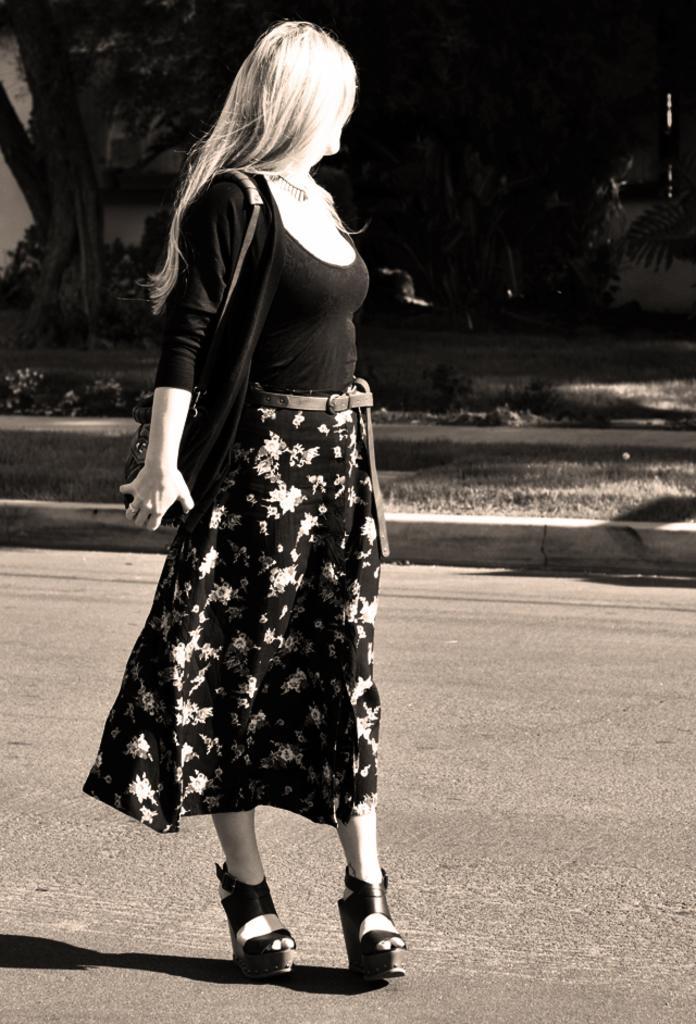Describe this image in one or two sentences. In this picture there is a woman walking on the road and carrying a bag. In the background of the image we can see grass, plants and tree. 